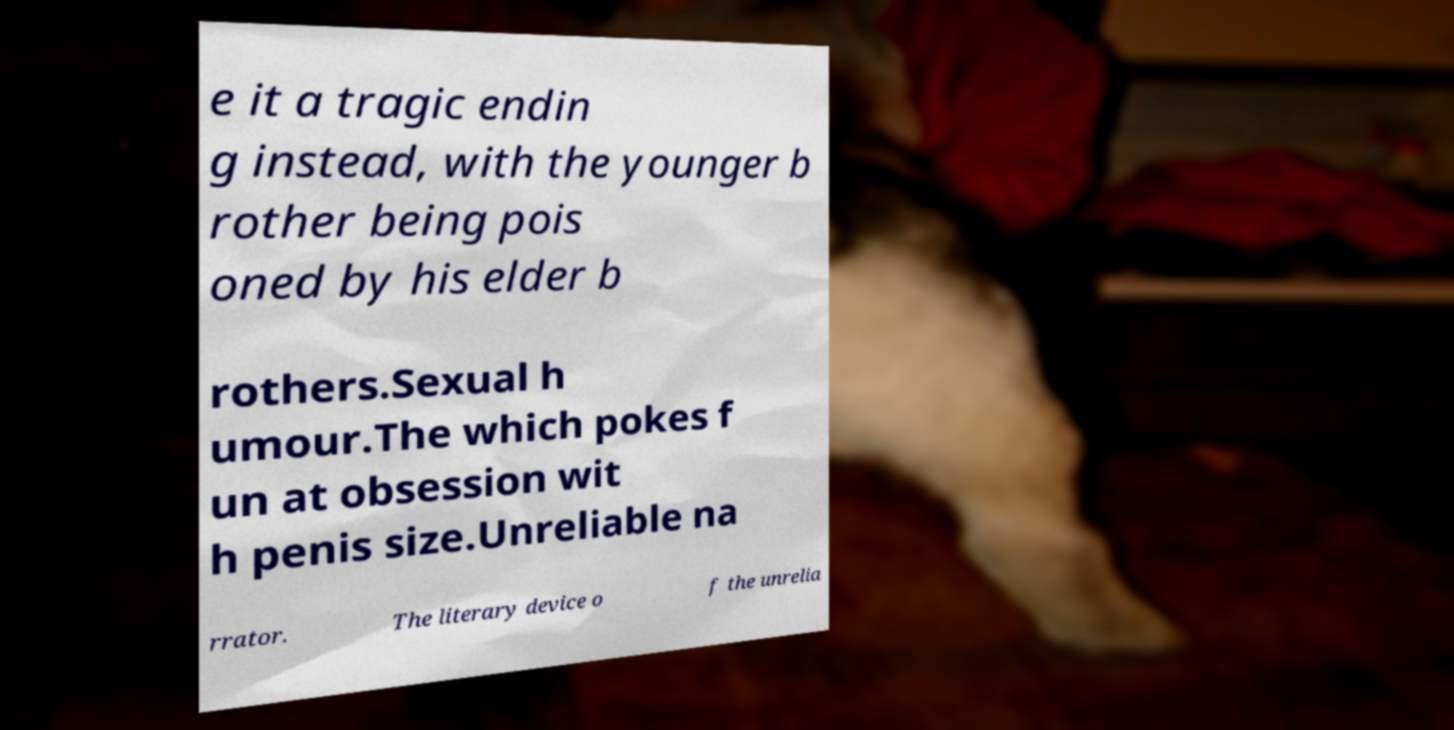Please identify and transcribe the text found in this image. e it a tragic endin g instead, with the younger b rother being pois oned by his elder b rothers.Sexual h umour.The which pokes f un at obsession wit h penis size.Unreliable na rrator. The literary device o f the unrelia 